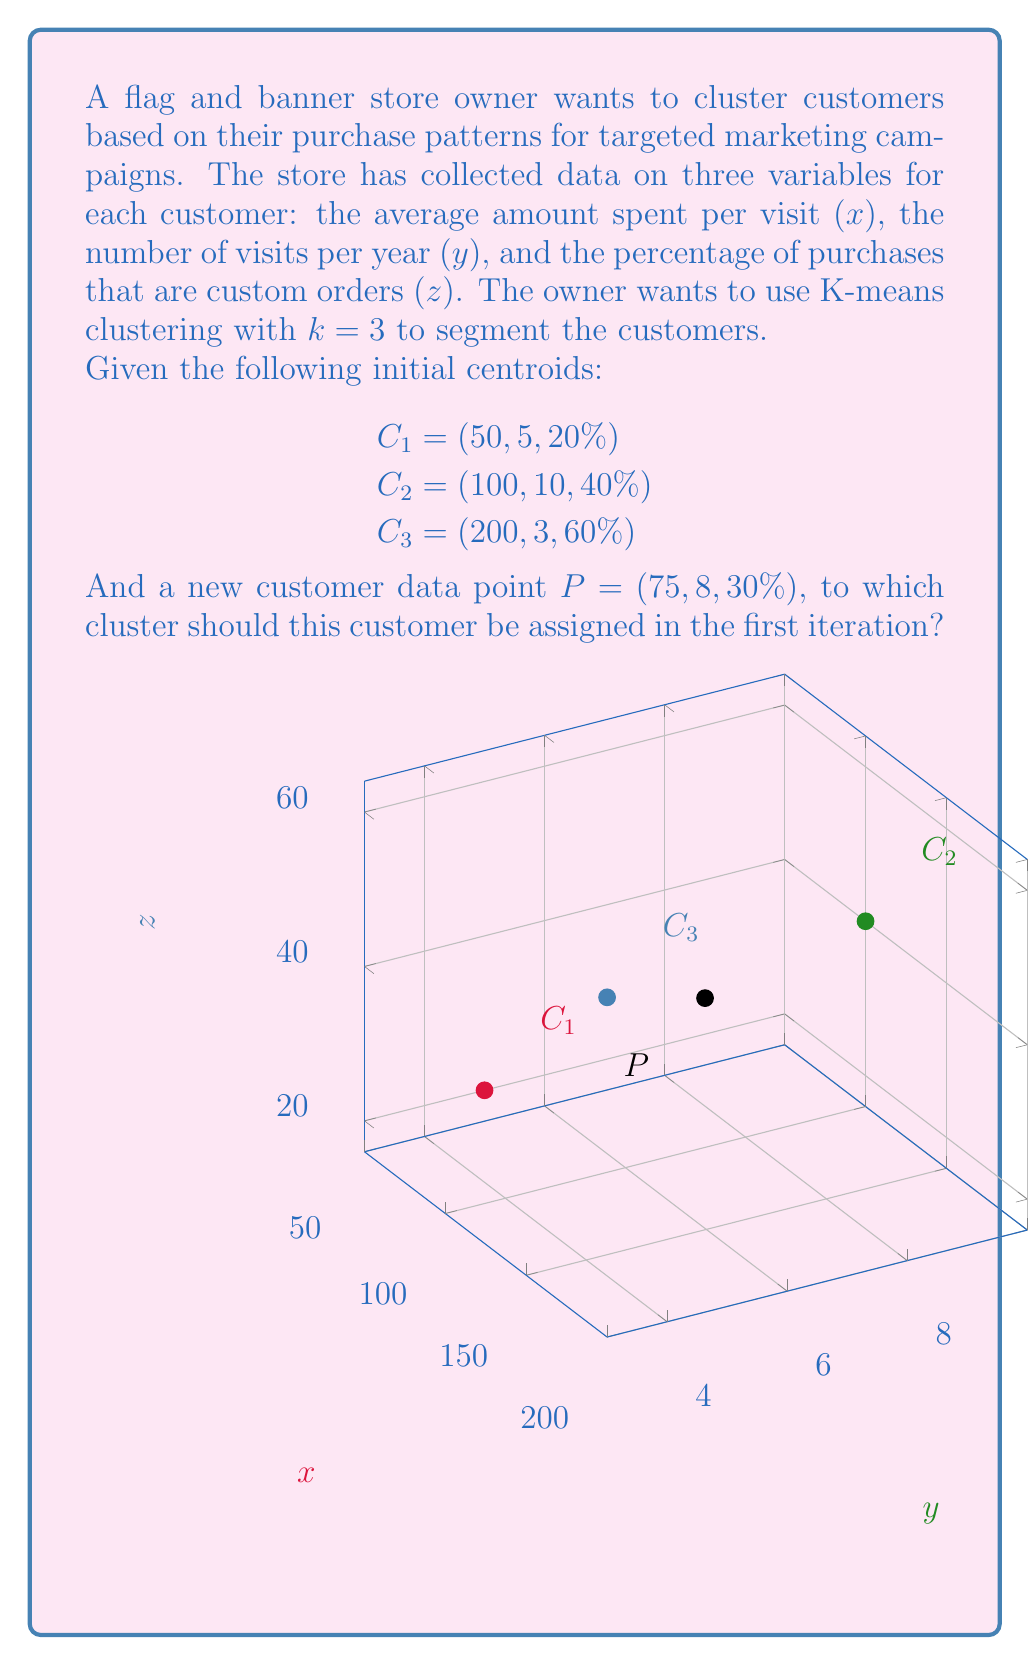Can you answer this question? To determine which cluster the new customer should be assigned to, we need to calculate the Euclidean distance between the customer's data point and each centroid. The customer will be assigned to the cluster with the closest centroid.

The Euclidean distance in 3D space is given by:

$$d = \sqrt{(x_2-x_1)^2 + (y_2-y_1)^2 + (z_2-z_1)^2}$$

Let's calculate the distance to each centroid:

1. Distance to $C_1$:
   $$d_1 = \sqrt{(75-50)^2 + (8-5)^2 + (30-20)^2} = \sqrt{625 + 9 + 100} = \sqrt{734} \approx 27.09$$

2. Distance to $C_2$:
   $$d_2 = \sqrt{(75-100)^2 + (8-10)^2 + (30-40)^2} = \sqrt{625 + 4 + 100} = \sqrt{729} = 27$$

3. Distance to $C_3$:
   $$d_3 = \sqrt{(75-200)^2 + (8-3)^2 + (30-60)^2} = \sqrt{15625 + 25 + 900} = \sqrt{16550} \approx 128.65$$

The shortest distance is to $C_2$, which is 27.
Answer: Cluster 2 